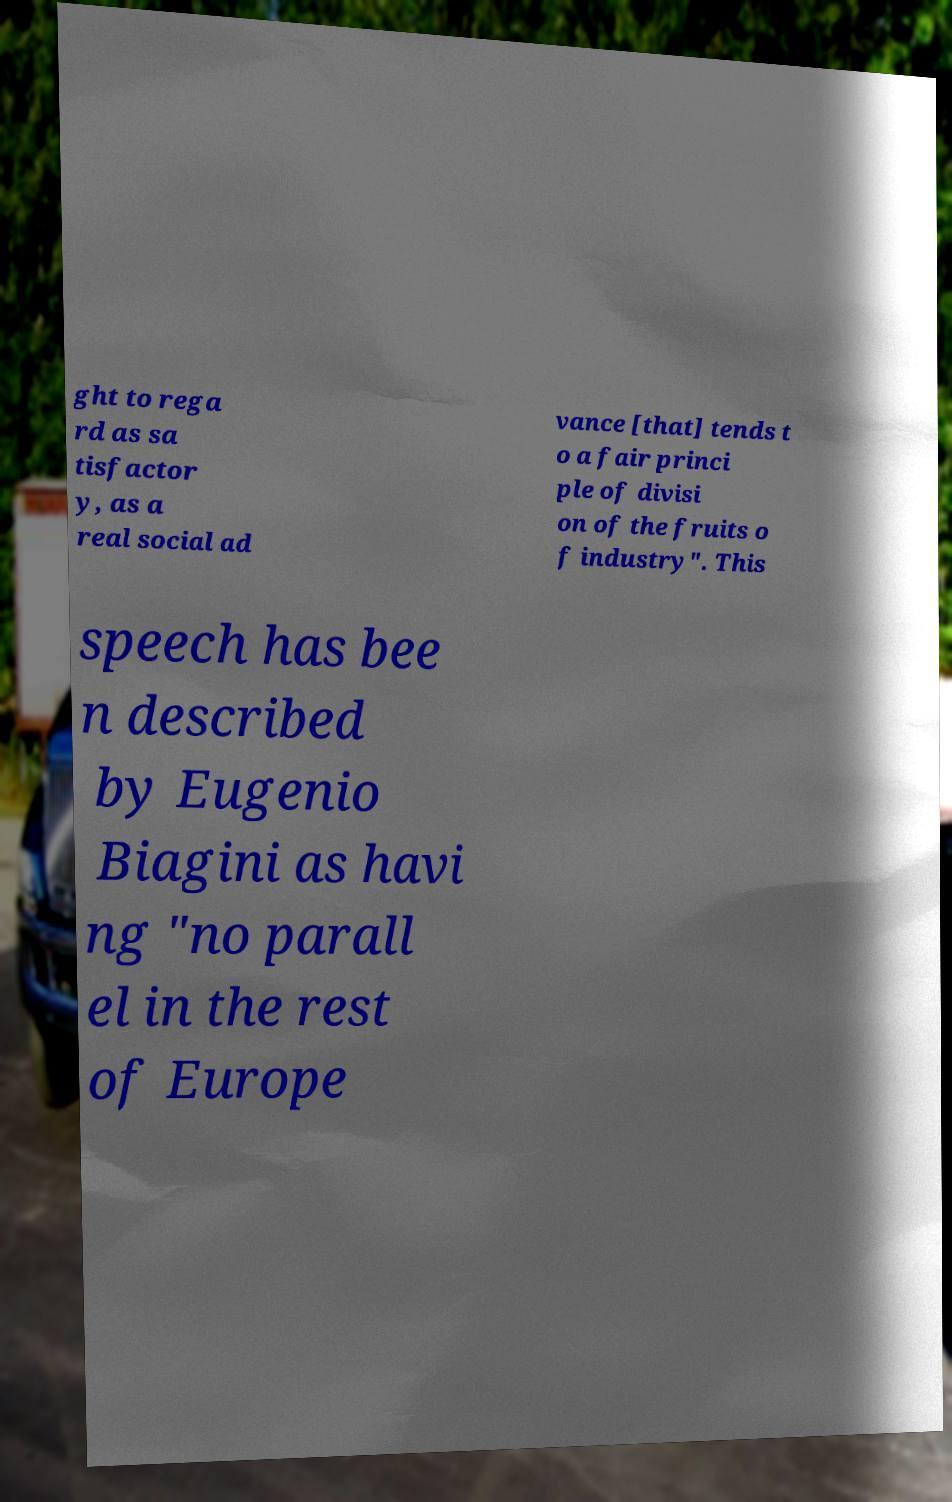There's text embedded in this image that I need extracted. Can you transcribe it verbatim? ght to rega rd as sa tisfactor y, as a real social ad vance [that] tends t o a fair princi ple of divisi on of the fruits o f industry". This speech has bee n described by Eugenio Biagini as havi ng "no parall el in the rest of Europe 